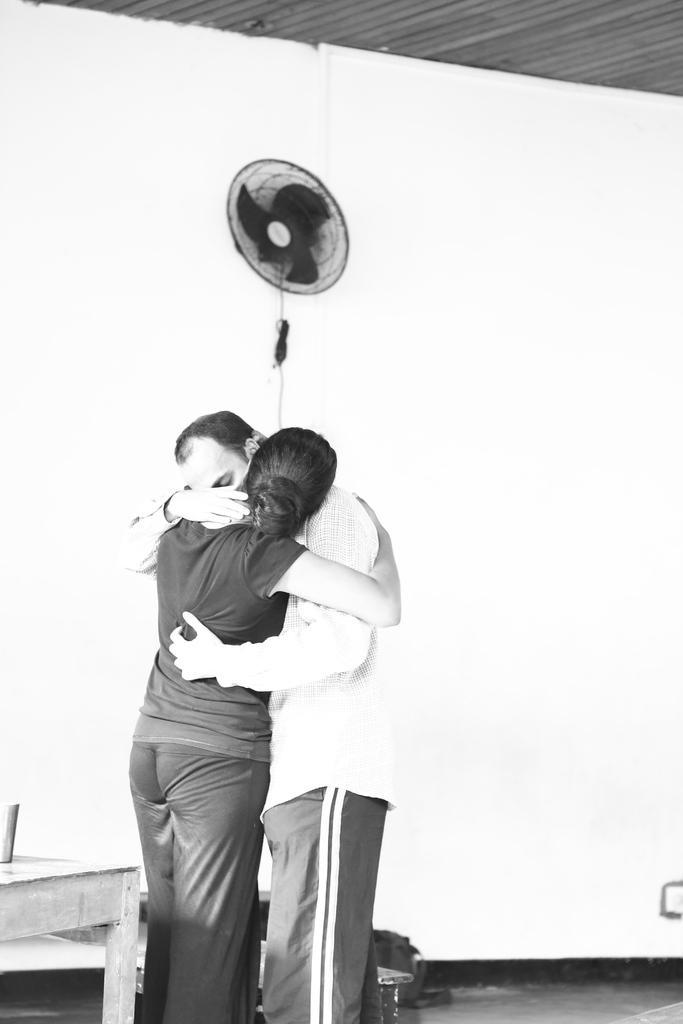How would you summarize this image in a sentence or two? It is a black and white image, there are two people hugging each other and behind them there is a wall and there is a fan attached to the wall. There is a table beside the people on the left side. 